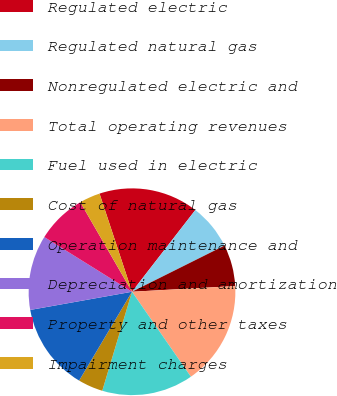<chart> <loc_0><loc_0><loc_500><loc_500><pie_chart><fcel>Regulated electric<fcel>Regulated natural gas<fcel>Nonregulated electric and<fcel>Total operating revenues<fcel>Fuel used in electric<fcel>Cost of natural gas<fcel>Operation maintenance and<fcel>Depreciation and amortization<fcel>Property and other taxes<fcel>Impairment charges<nl><fcel>15.58%<fcel>7.14%<fcel>6.49%<fcel>16.23%<fcel>14.29%<fcel>3.9%<fcel>13.64%<fcel>11.69%<fcel>7.79%<fcel>3.25%<nl></chart> 